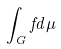Convert formula to latex. <formula><loc_0><loc_0><loc_500><loc_500>\int _ { G } f d \mu</formula> 